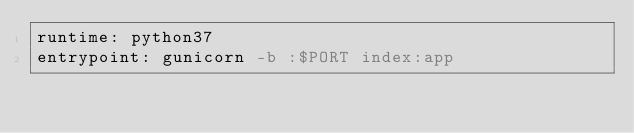Convert code to text. <code><loc_0><loc_0><loc_500><loc_500><_YAML_>runtime: python37
entrypoint: gunicorn -b :$PORT index:app</code> 